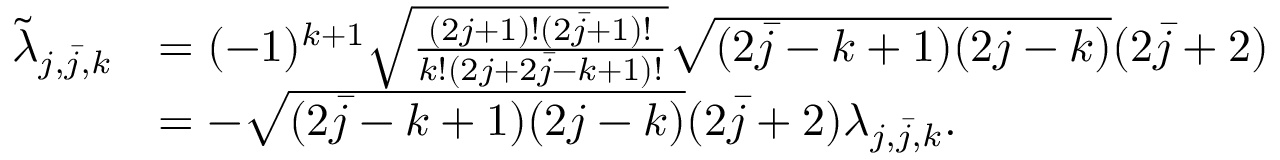Convert formula to latex. <formula><loc_0><loc_0><loc_500><loc_500>\begin{array} { r l } { \tilde { \lambda } _ { j , \bar { j } , k } } & { = ( - 1 ) ^ { k + 1 } \sqrt { \frac { ( 2 j + 1 ) ! ( 2 \bar { j } + 1 ) ! } { k ! ( 2 j + 2 \bar { j } - k + 1 ) ! } } \sqrt { ( 2 \bar { j } - k + 1 ) ( 2 j - k ) } ( 2 \bar { j } + 2 ) } \\ & { = - \sqrt { ( 2 \bar { j } - k + 1 ) ( 2 j - k ) } ( 2 \bar { j } + 2 ) \lambda _ { j , \bar { j } , k } . } \end{array}</formula> 